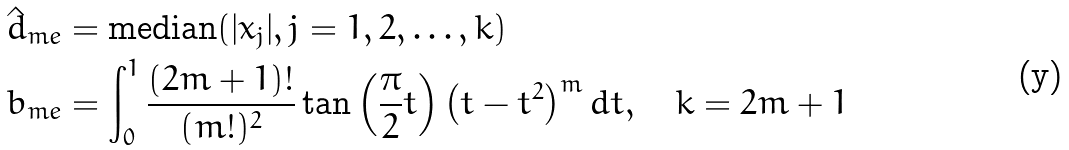Convert formula to latex. <formula><loc_0><loc_0><loc_500><loc_500>\hat { d } _ { m e } & = \text {median} ( | x _ { j } | , j = 1 , 2 , \dots , k ) \\ b _ { m e } & = \int _ { 0 } ^ { 1 } \frac { ( 2 m + 1 ) ! } { ( m ! ) ^ { 2 } } \tan \left ( \frac { \pi } { 2 } t \right ) \left ( t - t ^ { 2 } \right ) ^ { m } d t , \quad k = 2 m + 1</formula> 